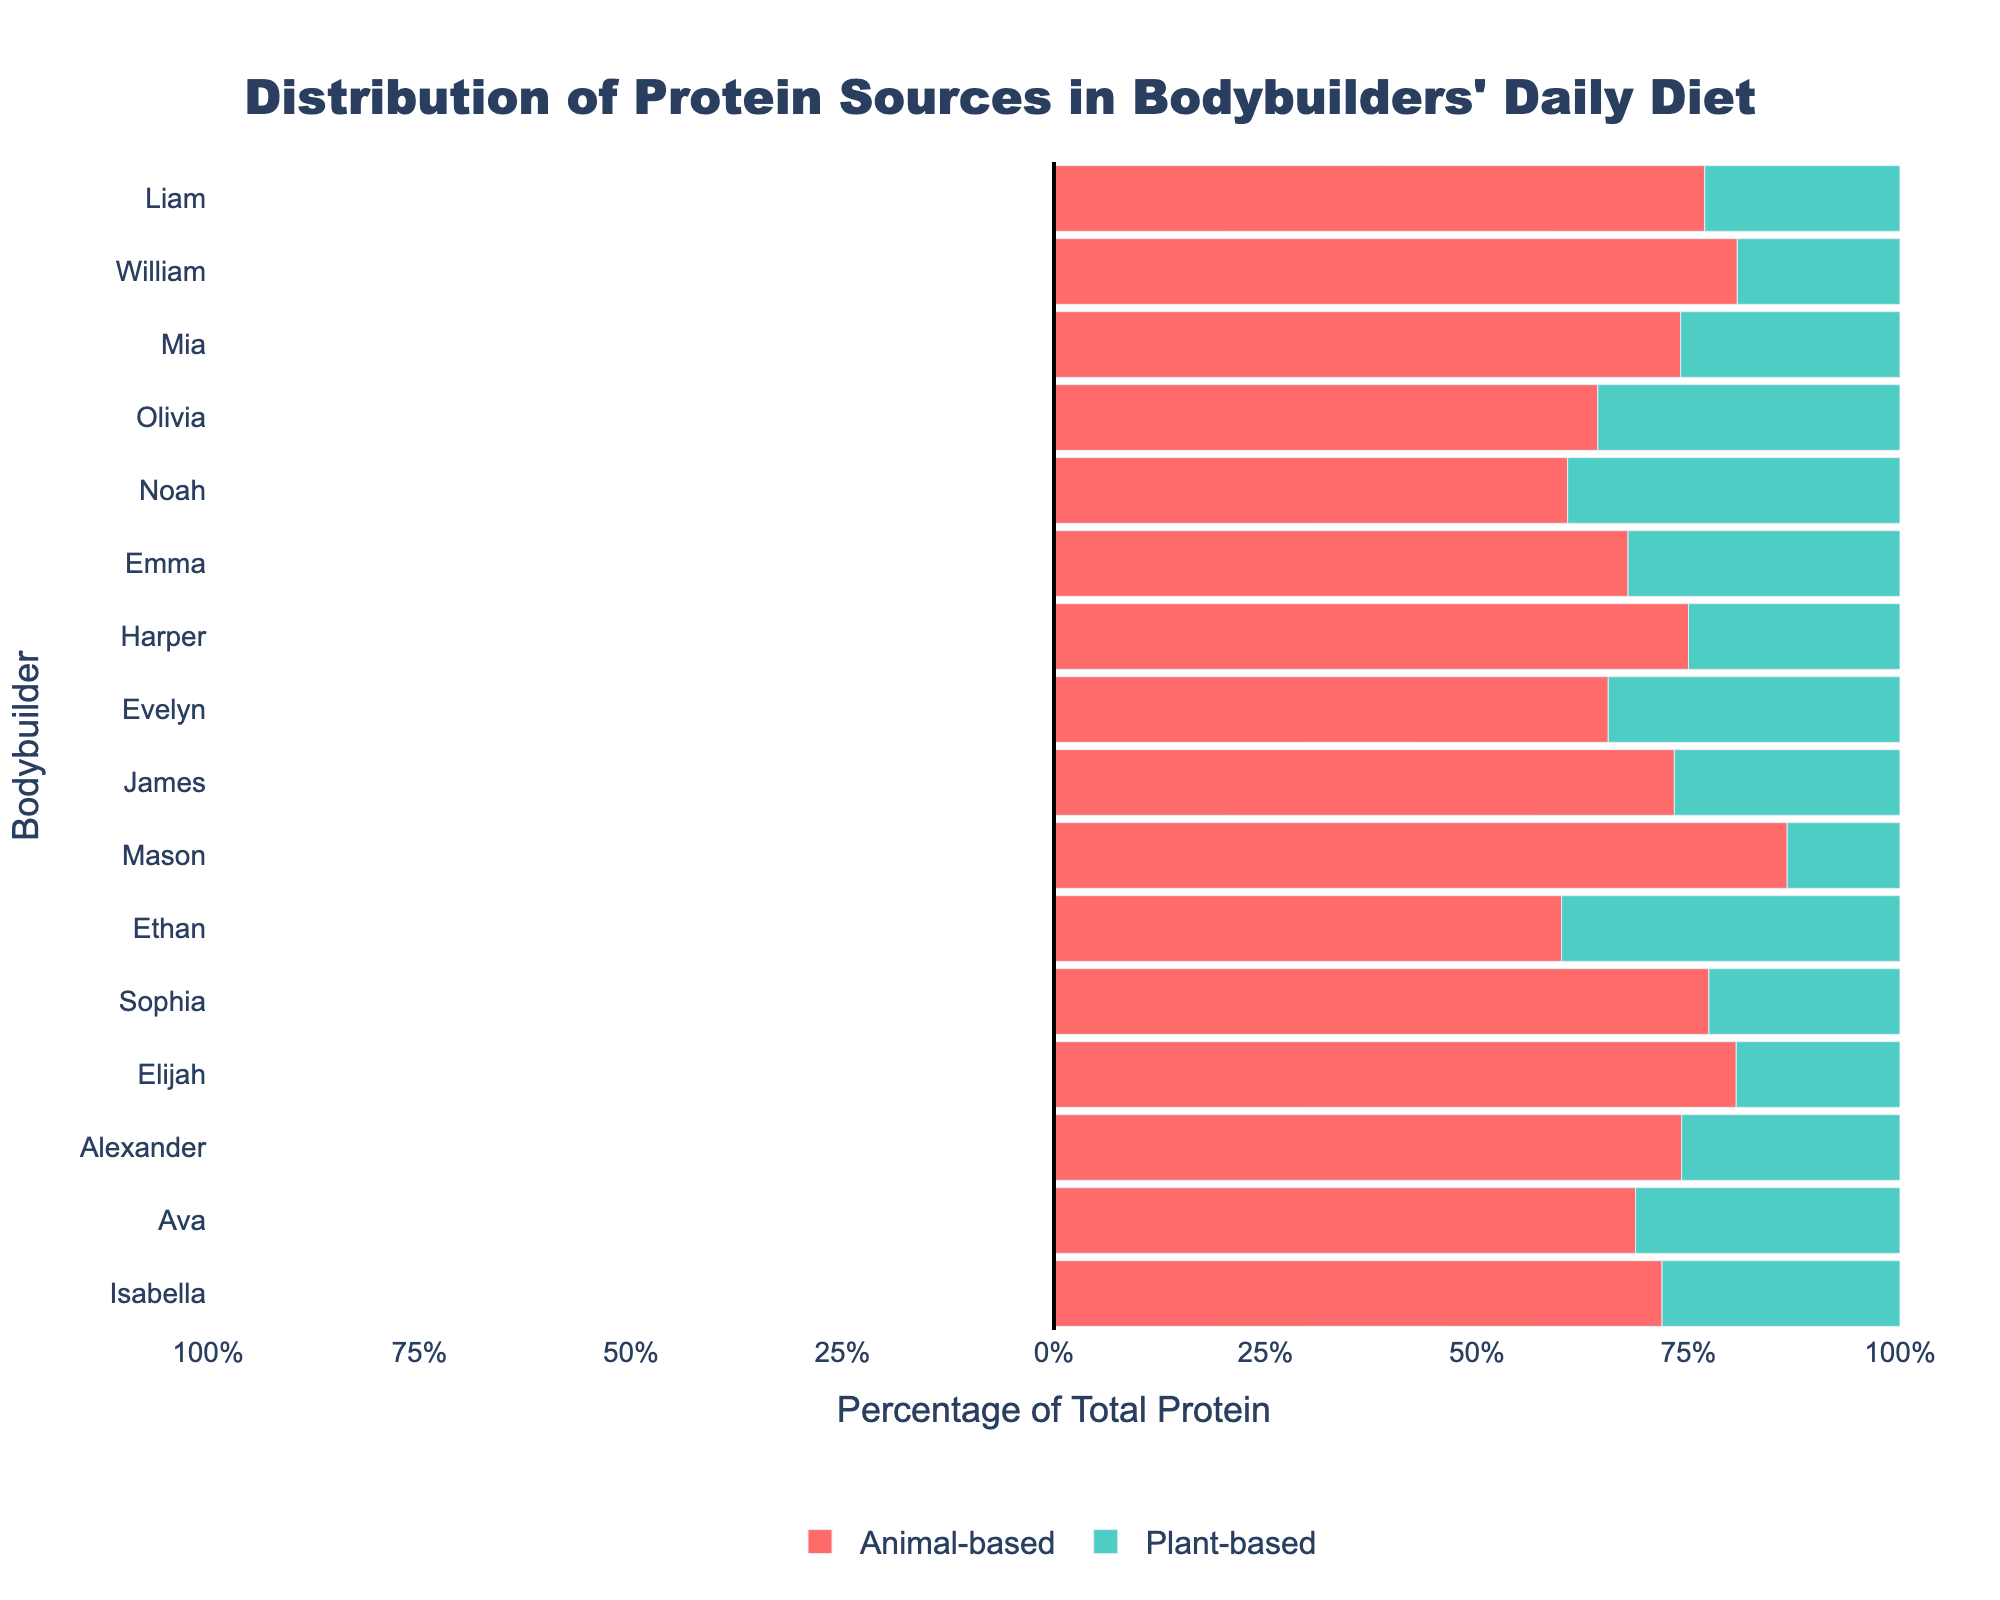Which bodybuilder has the highest percentage of animal-based protein? Observe the length of the red bars representing animal-based protein for each bodybuilder. The longest red bar indicates the highest percentage. Mason has the longest red bar.
Answer: Mason Which bodybuilder has the most balanced protein distribution (nearly equal amounts of plant-based and animal-based protein)? Look for bodybuilders whose red and green bars are of similar length. Noah's red and green bars are almost equal in length.
Answer: Noah How much more animal-based protein does James consume compared to Liam? James consumes 110g of animal-based protein; Liam consumes 100g. The difference is \(110g - 100g = 10g\).
Answer: 10g Which bodybuilder consumes the highest total protein, and how much is it? Find the annotation for the highest total protein value. Ava and Isabella both have the highest total protein of 160g.
Answer: Ava, Isabella What percentage of Harper's total protein comes from plant-based sources? Harper consumes 35g of plant-based protein out of a total of 140g. The percentage is \(\frac{35}{140} \times 100 = 25\%\).
Answer: 25% Which bodybuilder consumes the least plant-based protein, and how much is it? Look for the shortest green bar. Mason's green bar is the shortest, and he consumes 20g of plant-based protein.
Answer: Mason How does Ethan's plant-based protein intake compare to Evelyn's? Ethan consumes 60g of plant-based protein; Evelyn consumes 50g. Ethan consumes 10g more plant-based protein than Evelyn.
Answer: Ethan consumes 10g more What's the average total protein intake among bodybuilders shown? Sum all total protein intakes and divide by the number of bodybuilders. The sum is \(150+155+130+140+140+140+130+160+155+160+150+135+150+140+155+145 = 2145\). There are 16 bodybuilders, so the average is \(\frac{2145}{16} \approx 134.06\).
Answer: 134.06g Which bodybuilder has the highest percentage of plant-based protein, and what is that percentage? Elijah consumes 30g of plant-based protein out of a total of 155g. Observing the green bars, Ethan's plant-based percentage is the highest at 40%, calculated by \(\frac{60}{150} \times 100\).
Answer: Ethan, 40% Compare the total protein intake between Sophia and Alexander. Who consumes more, and by how much? Sophia consumes 155g of total protein; Alexander also consumes 155g. So, they consume the same amount of total protein.
Answer: Same amount 